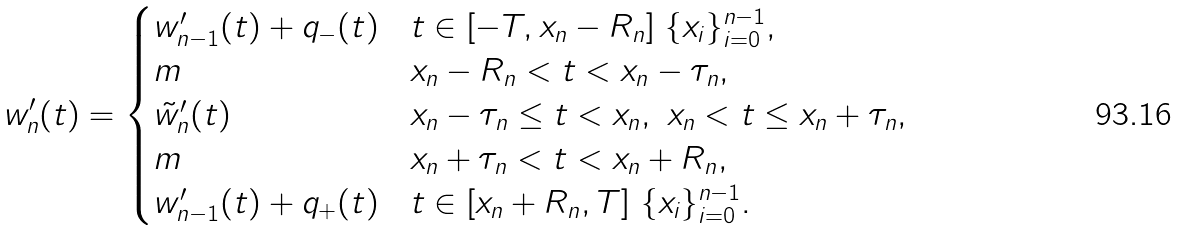Convert formula to latex. <formula><loc_0><loc_0><loc_500><loc_500>w _ { n } ^ { \prime } ( t ) = \begin{cases} w _ { n - 1 } ^ { \prime } ( t ) + q _ { - } ( t ) & t \in [ - T , x _ { n } - R _ { n } ] \ \{ x _ { i } \} _ { i = 0 } ^ { n - 1 } , \\ m & x _ { n } - R _ { n } < t < x _ { n } - \tau _ { n } , \\ \tilde { w } _ { n } ^ { \prime } ( t ) & x _ { n } - \tau _ { n } \leq t < x _ { n } , \ x _ { n } < t \leq x _ { n } + \tau _ { n } , \\ m & x _ { n } + \tau _ { n } < t < x _ { n } + R _ { n } , \\ w _ { n - 1 } ^ { \prime } ( t ) + q _ { + } ( t ) & t \in [ x _ { n } + R _ { n } , T ] \ \{ x _ { i } \} _ { i = 0 } ^ { n - 1 } . \end{cases}</formula> 